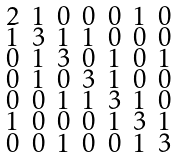Convert formula to latex. <formula><loc_0><loc_0><loc_500><loc_500>\begin{smallmatrix} 2 & 1 & 0 & 0 & 0 & 1 & 0 \\ 1 & 3 & 1 & 1 & 0 & 0 & 0 \\ 0 & 1 & 3 & 0 & 1 & 0 & 1 \\ 0 & 1 & 0 & 3 & 1 & 0 & 0 \\ 0 & 0 & 1 & 1 & 3 & 1 & 0 \\ 1 & 0 & 0 & 0 & 1 & 3 & 1 \\ 0 & 0 & 1 & 0 & 0 & 1 & 3 \end{smallmatrix}</formula> 